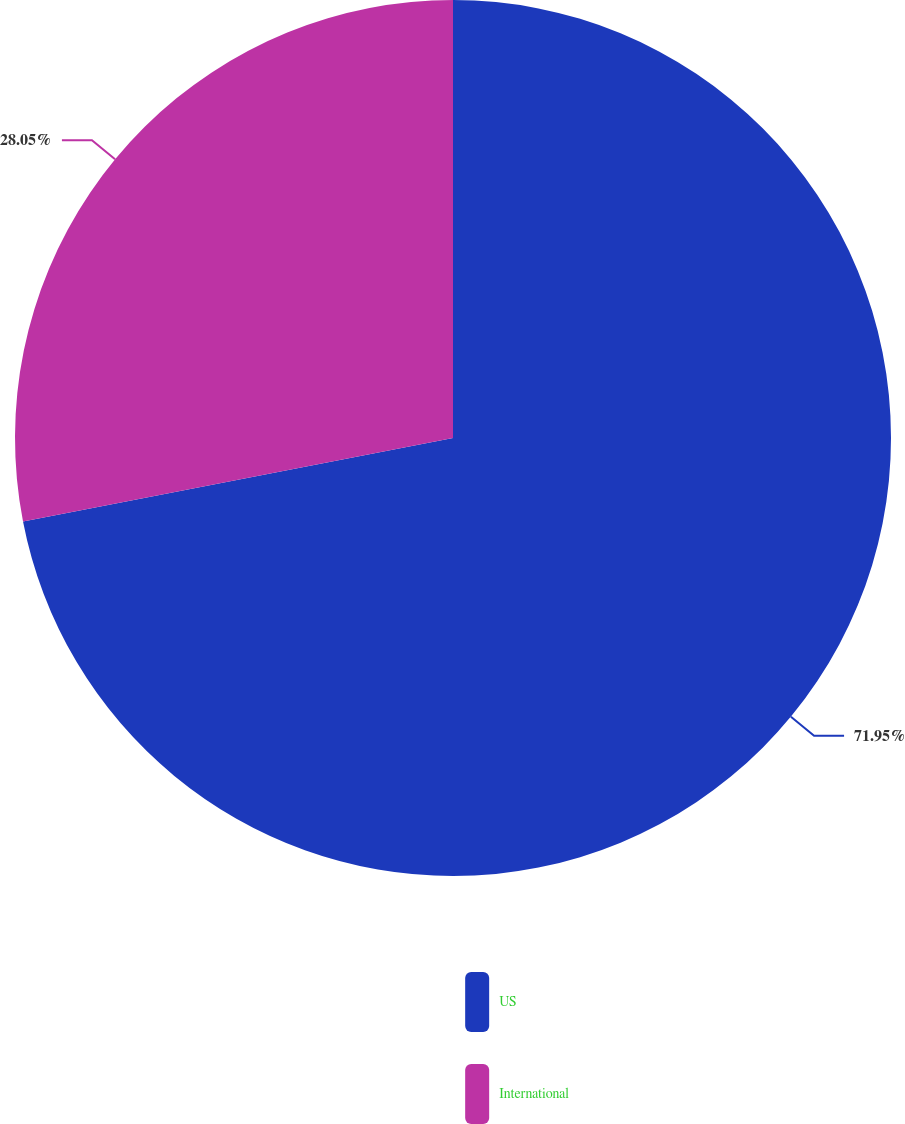Convert chart to OTSL. <chart><loc_0><loc_0><loc_500><loc_500><pie_chart><fcel>US<fcel>International<nl><fcel>71.95%<fcel>28.05%<nl></chart> 